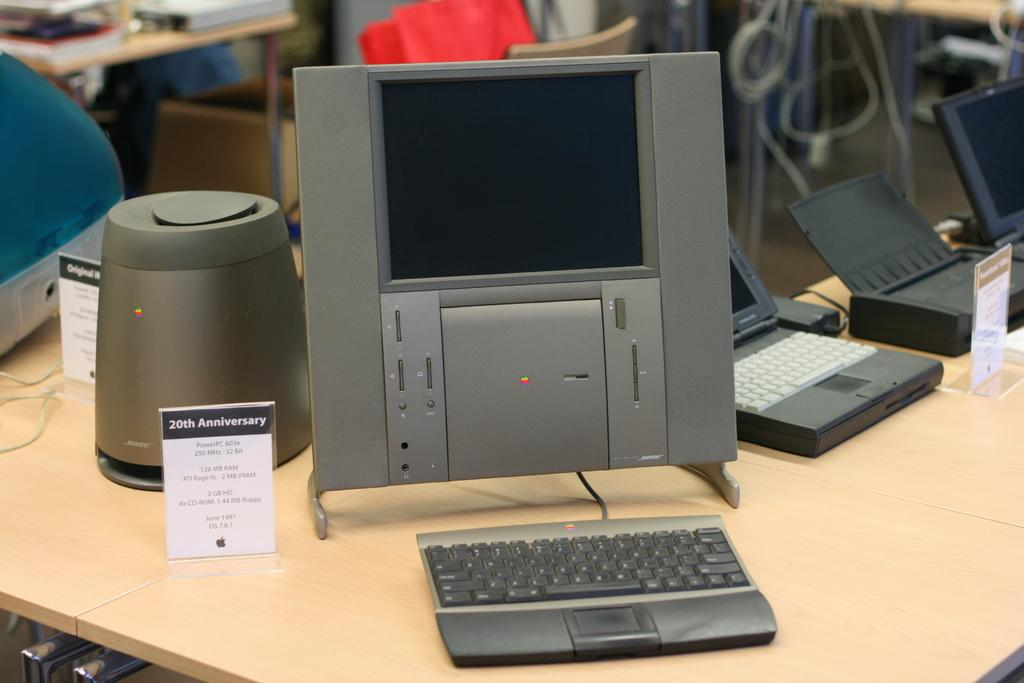<image>
Summarize the visual content of the image. a showing of the 20th anniversary of a power pc 